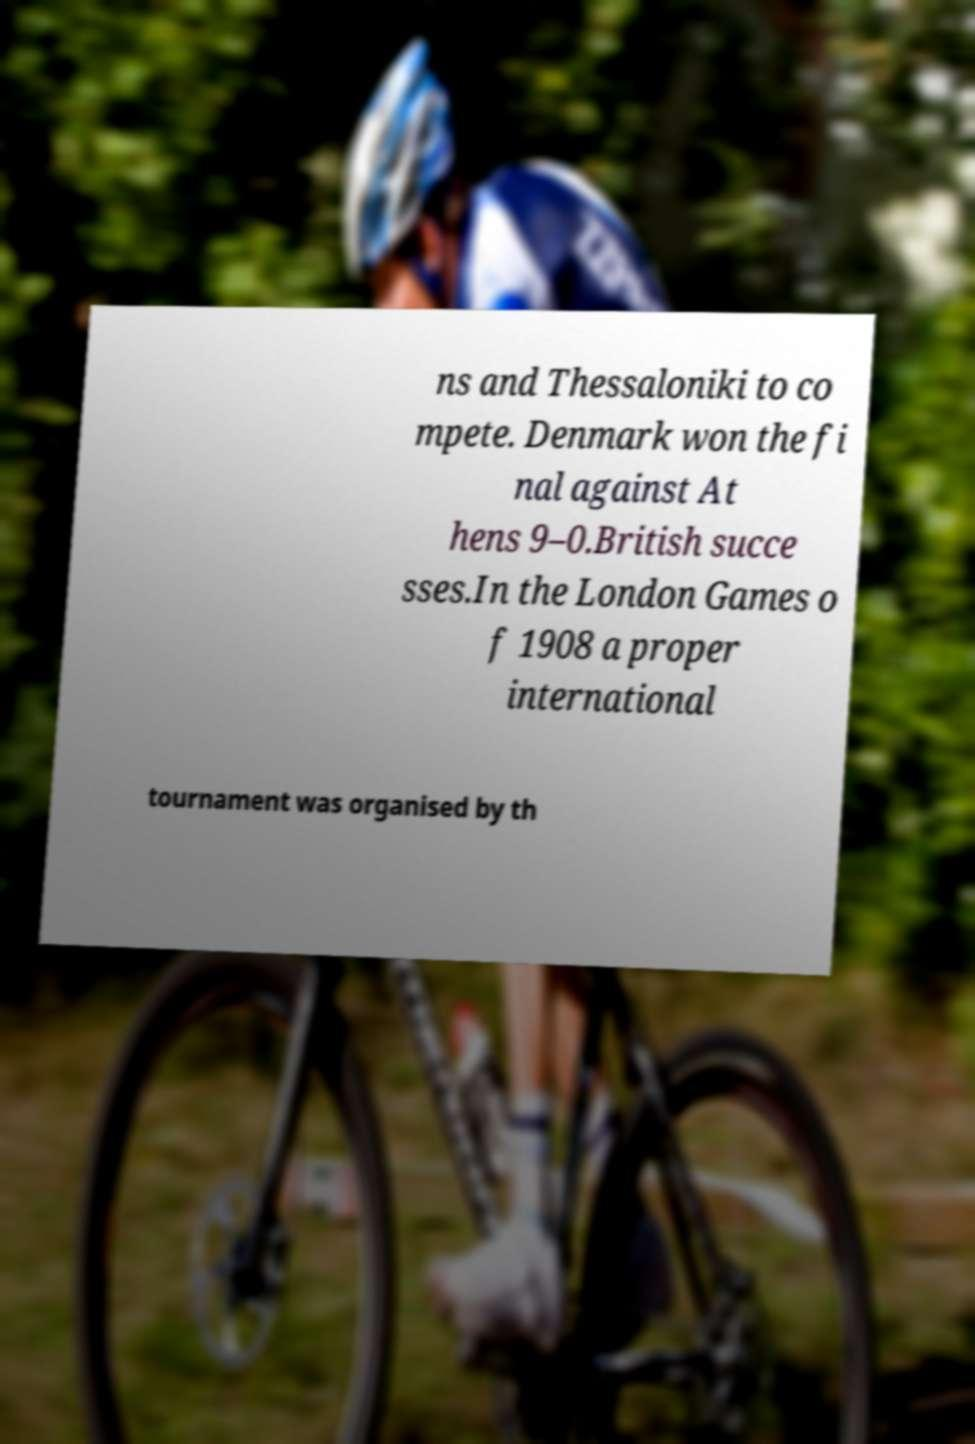I need the written content from this picture converted into text. Can you do that? ns and Thessaloniki to co mpete. Denmark won the fi nal against At hens 9–0.British succe sses.In the London Games o f 1908 a proper international tournament was organised by th 